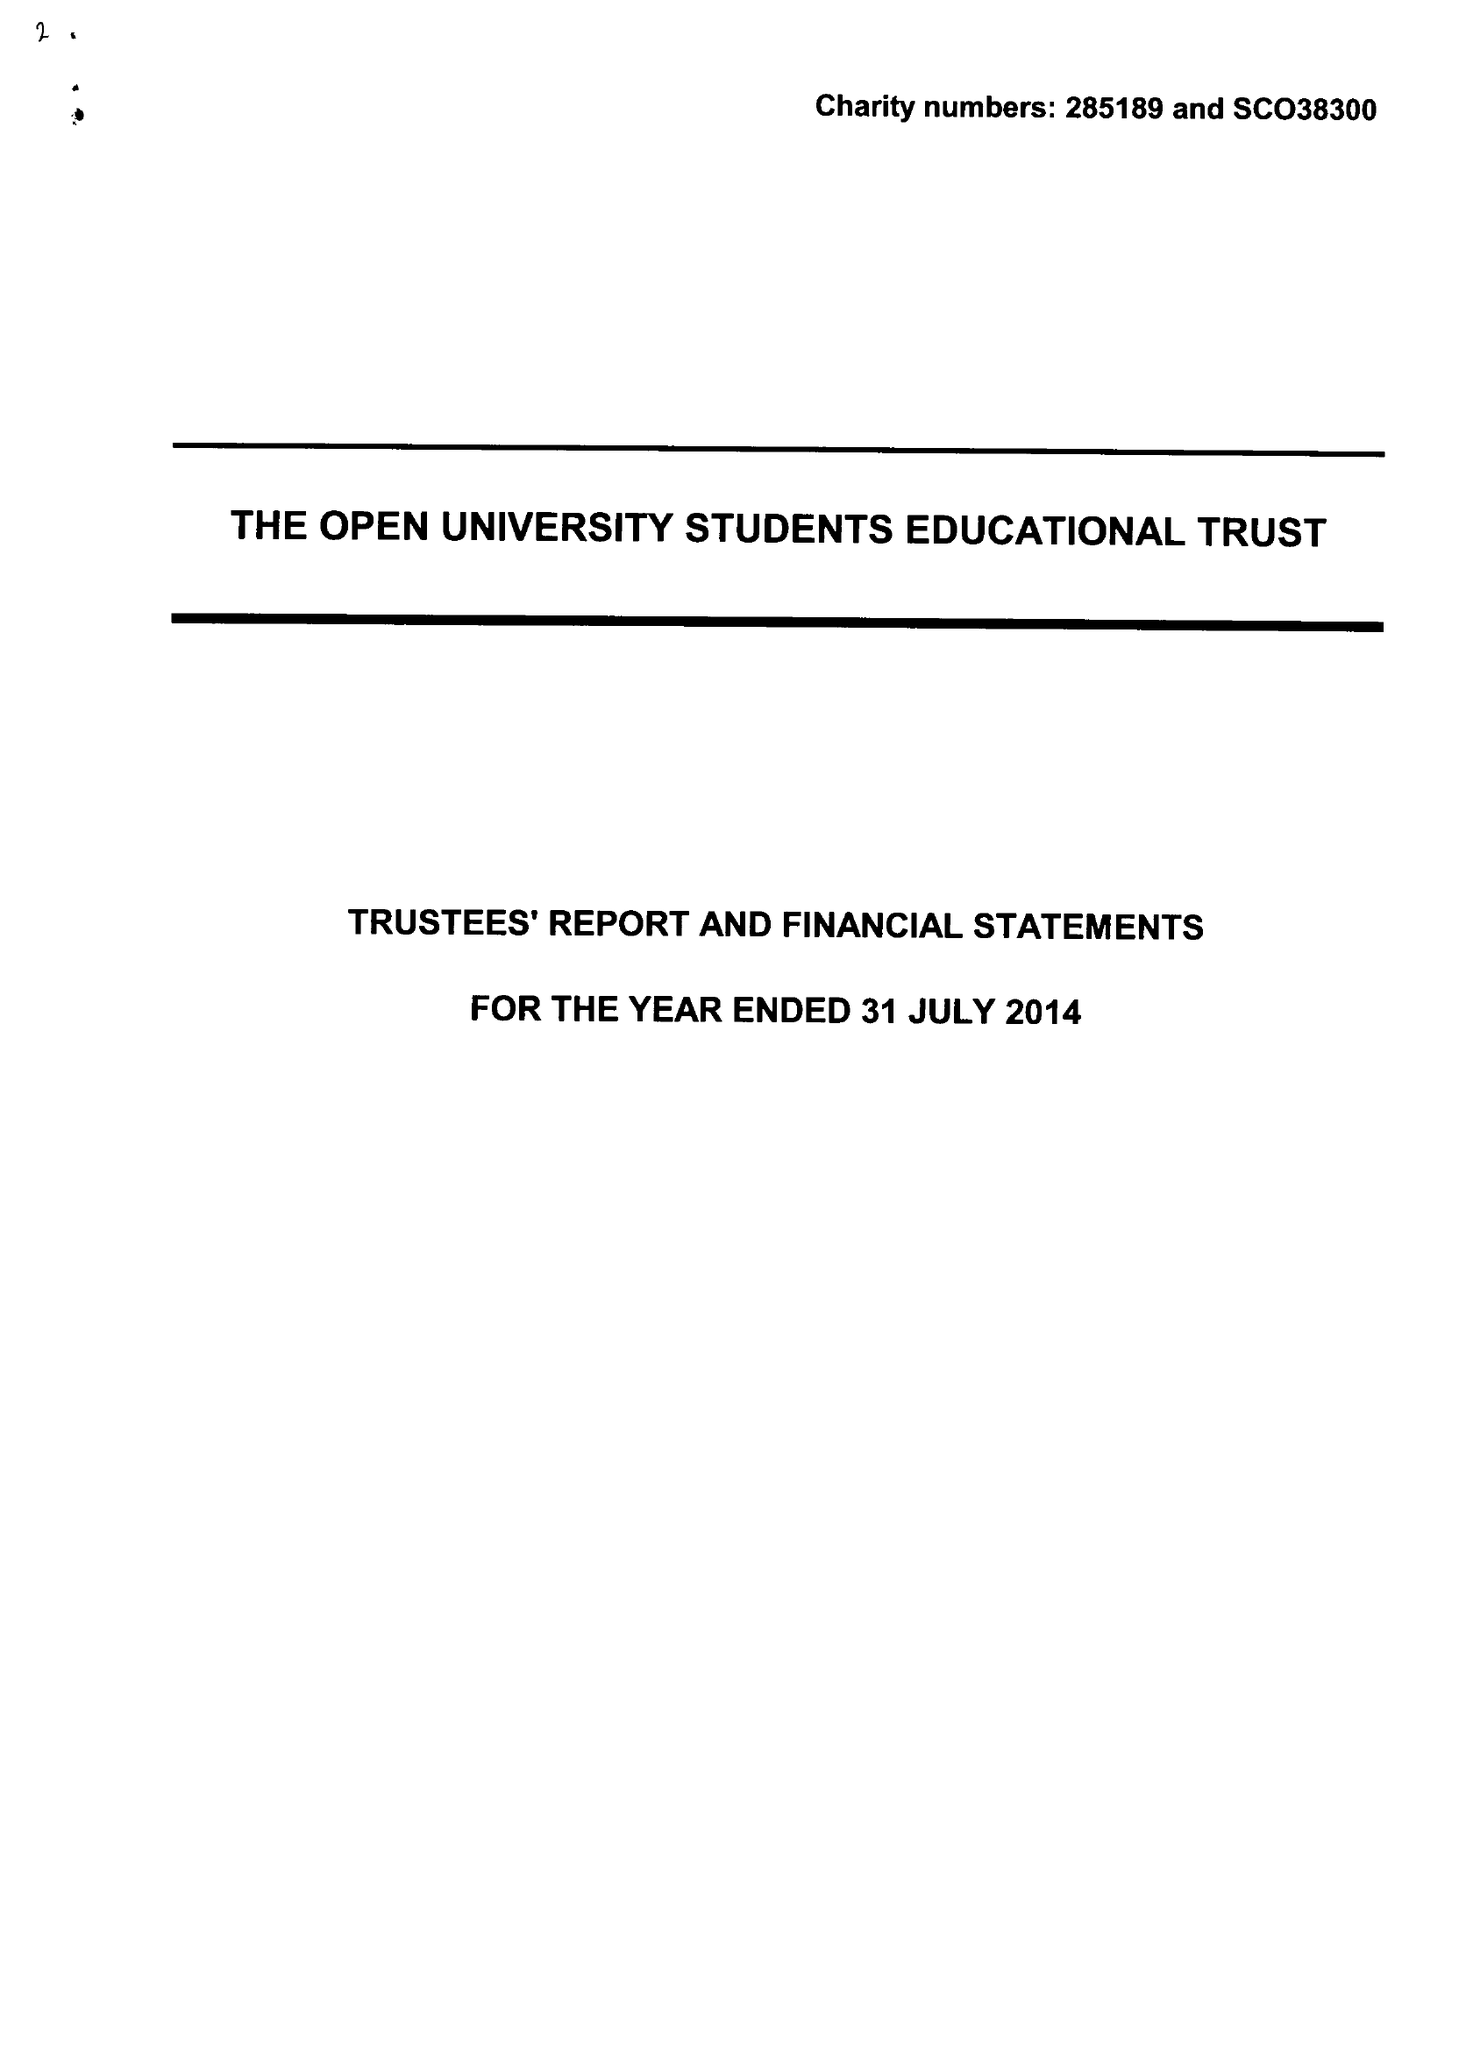What is the value for the charity_name?
Answer the question using a single word or phrase. The Open University Students Educational Trust 